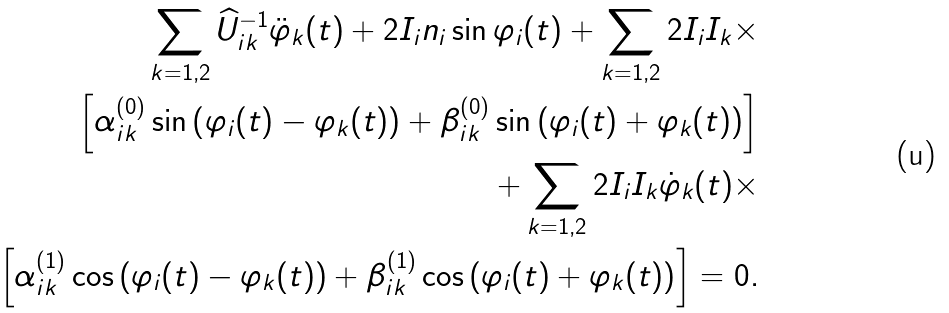<formula> <loc_0><loc_0><loc_500><loc_500>\sum _ { k = 1 , 2 } \widehat { U } _ { i k } ^ { - 1 } \ddot { \varphi } _ { k } ( t ) + 2 I _ { i } n _ { i } \sin \varphi _ { i } ( t ) + \sum _ { k = 1 , 2 } 2 I _ { i } I _ { k } \times \\ \left [ \alpha _ { i k } ^ { ( 0 ) } \sin \left ( \varphi _ { i } ( t ) - \varphi _ { k } ( t ) \right ) + \beta _ { i k } ^ { ( 0 ) } \sin \left ( \varphi _ { i } ( t ) + \varphi _ { k } ( t ) \right ) \right ] \\ + \sum _ { k = 1 , 2 } 2 I _ { i } I _ { k } \dot { \varphi } _ { k } ( t ) \times \\ \left [ \alpha _ { i k } ^ { ( 1 ) } \cos \left ( \varphi _ { i } ( t ) - \varphi _ { k } ( t ) \right ) + \beta _ { i k } ^ { ( 1 ) } \cos \left ( \varphi _ { i } ( t ) + \varphi _ { k } ( t ) \right ) \right ] = 0 .</formula> 